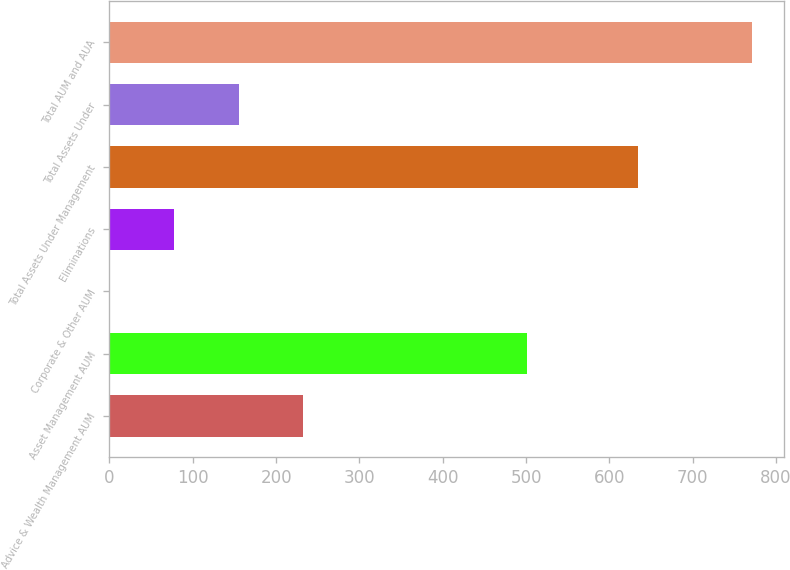Convert chart to OTSL. <chart><loc_0><loc_0><loc_500><loc_500><bar_chart><fcel>Advice & Wealth Management AUM<fcel>Asset Management AUM<fcel>Corporate & Other AUM<fcel>Eliminations<fcel>Total Assets Under Management<fcel>Total Assets Under<fcel>Total AUM and AUA<nl><fcel>232.02<fcel>500.8<fcel>0.9<fcel>77.94<fcel>634.3<fcel>154.98<fcel>771.3<nl></chart> 